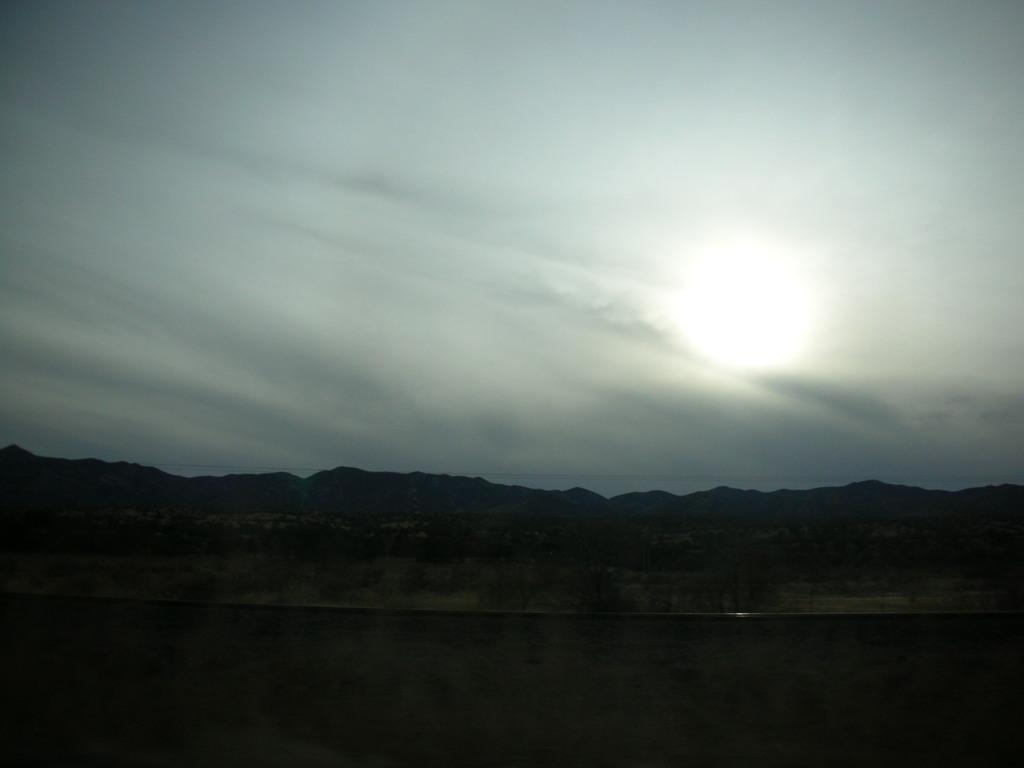What is the location of the image in relation to the city? The image is taken from outside of the city. What natural features can be seen in the image? There are mountains and rocks visible in the image. What is visible at the top of the image? The sky is visible at the top of the image, and the moon is visible in the sky. What is the color of the bottom part of the image? The bottom of the image appears to be black. Can you tell me how many chess pieces are on the rocks in the image? There are no chess pieces present in the image; it features mountains, rocks, and the sky. What type of ray is visible in the image? There is no ray visible in the image; it features mountains, rocks, and the sky. 